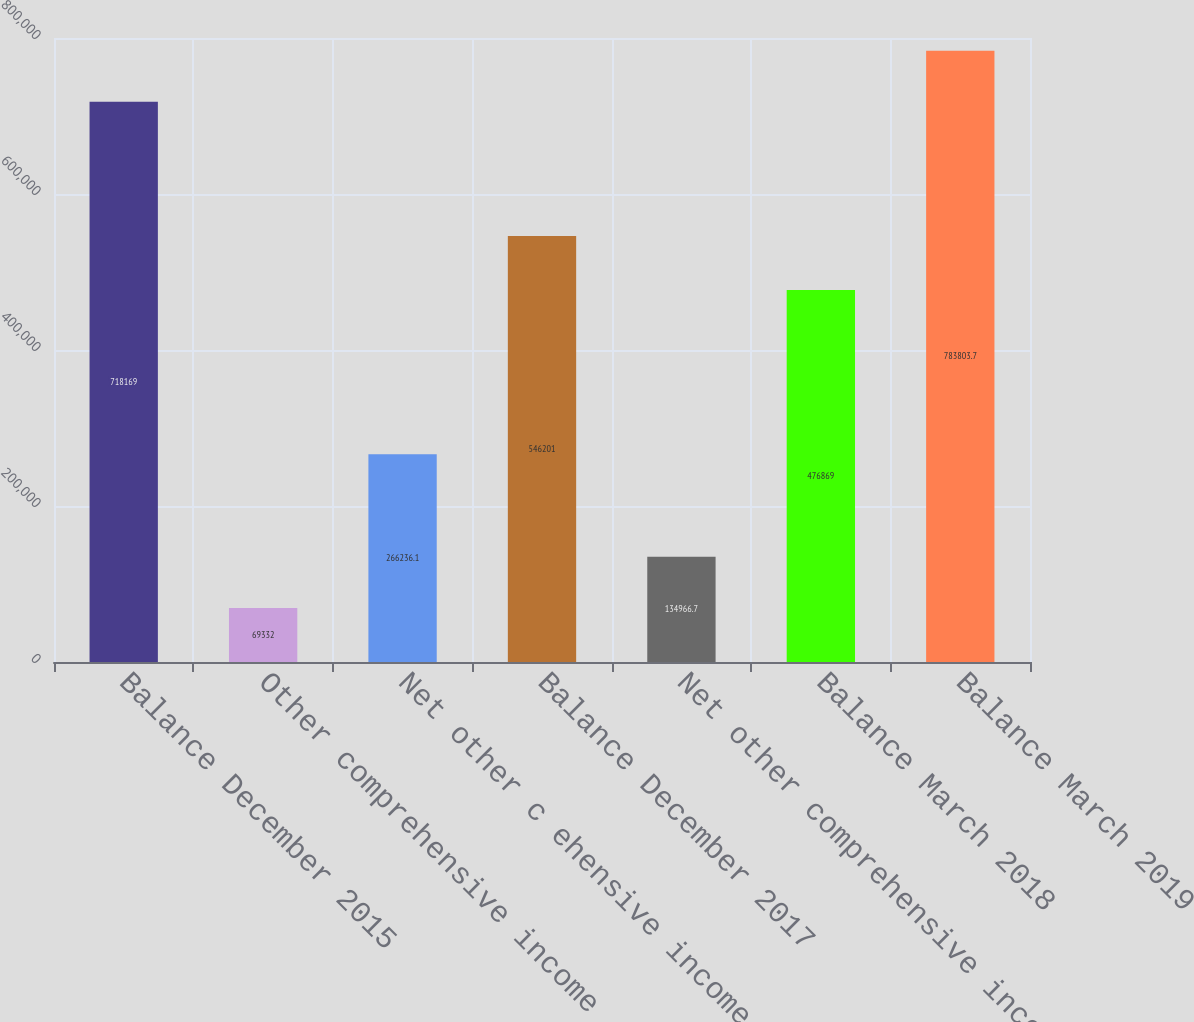Convert chart to OTSL. <chart><loc_0><loc_0><loc_500><loc_500><bar_chart><fcel>Balance December 2015<fcel>Other comprehensive income<fcel>Net other c ehensive income<fcel>Balance December 2017<fcel>Net other comprehensive income<fcel>Balance March 2018<fcel>Balance March 2019<nl><fcel>718169<fcel>69332<fcel>266236<fcel>546201<fcel>134967<fcel>476869<fcel>783804<nl></chart> 